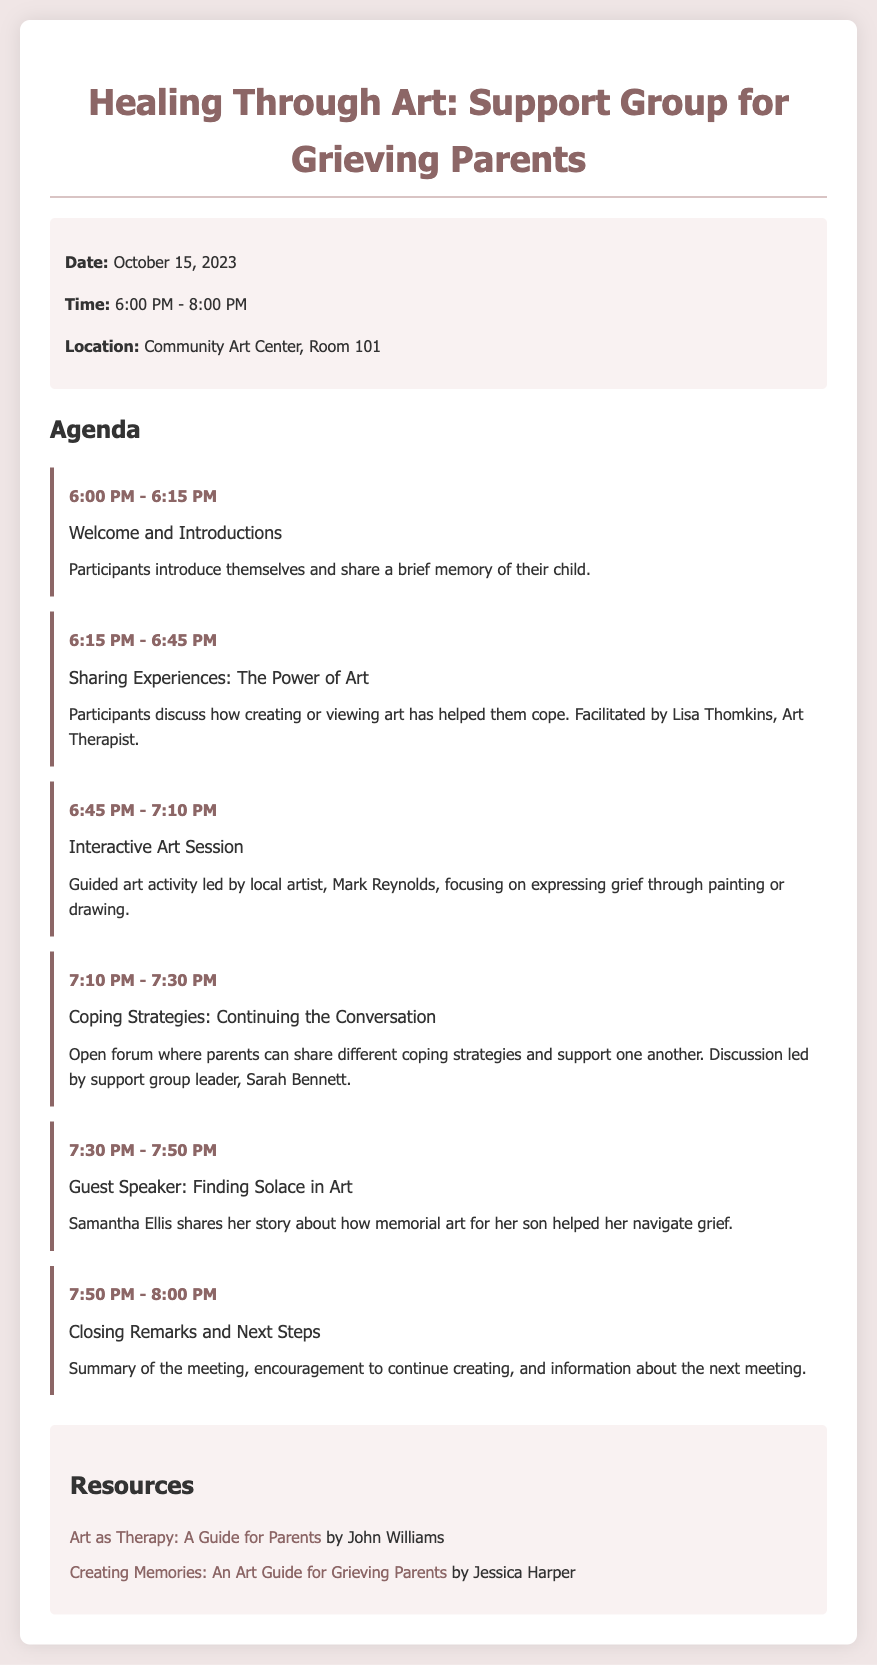what is the date of the meeting? The date of the meeting is explicitly mentioned in the meeting info section of the document.
Answer: October 15, 2023 what is the location of the support group meeting? The location is stated in the meeting info section and specifies where the meeting will take place.
Answer: Community Art Center, Room 101 who is the guest speaker at the meeting? The name of the guest speaker who will present during the meeting is listed in the agenda section.
Answer: Samantha Ellis how long is the interactive art session planned to last? The duration of the interactive art session is specified within the agenda for that activity.
Answer: 25 minutes what is the first activity listed in the agenda? The first item in the agenda outlines the initial activity that will take place at the meeting.
Answer: Welcome and Introductions who leads the discussion on coping strategies? The name of the person leading the discussion about coping strategies is identified in the agenda section.
Answer: Sarah Bennett what type of art session is included in the agenda? The type of activity is described in the agenda where creativity is encouraged and described as a session.
Answer: Interactive Art Session what will participants discuss during the "Sharing Experiences" activity? This activity outlines a specific topic of discussion among participants during that segment of the meeting.
Answer: How creating or viewing art has helped them cope how many minutes is allocated for "Closing Remarks and Next Steps"? The duration for this closing portion is detailed in the agenda under that specific activity.
Answer: 10 minutes 